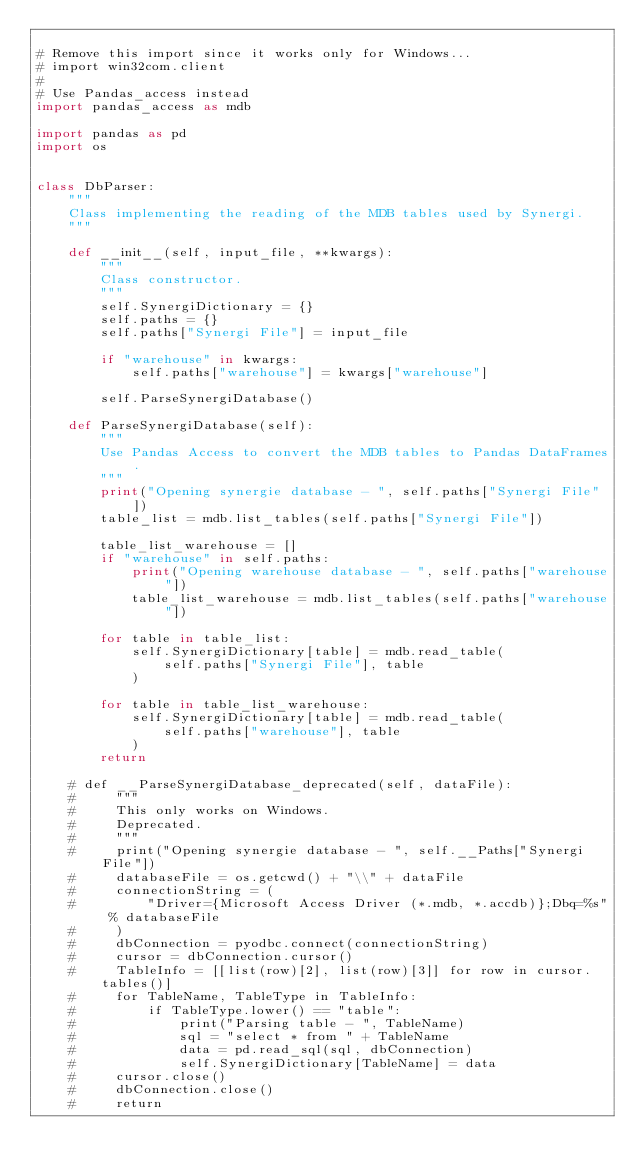<code> <loc_0><loc_0><loc_500><loc_500><_Python_>
# Remove this import since it works only for Windows...
# import win32com.client
#
# Use Pandas_access instead
import pandas_access as mdb

import pandas as pd
import os


class DbParser:
    """
    Class implementing the reading of the MDB tables used by Synergi.
    """

    def __init__(self, input_file, **kwargs):
        """
        Class constructor.
        """
        self.SynergiDictionary = {}
        self.paths = {}
        self.paths["Synergi File"] = input_file

        if "warehouse" in kwargs:
            self.paths["warehouse"] = kwargs["warehouse"]

        self.ParseSynergiDatabase()

    def ParseSynergiDatabase(self):
        """
        Use Pandas Access to convert the MDB tables to Pandas DataFrames.
        """
        print("Opening synergie database - ", self.paths["Synergi File"])
        table_list = mdb.list_tables(self.paths["Synergi File"])

        table_list_warehouse = []
        if "warehouse" in self.paths:
            print("Opening warehouse database - ", self.paths["warehouse"])
            table_list_warehouse = mdb.list_tables(self.paths["warehouse"])

        for table in table_list:
            self.SynergiDictionary[table] = mdb.read_table(
                self.paths["Synergi File"], table
            )

        for table in table_list_warehouse:
            self.SynergiDictionary[table] = mdb.read_table(
                self.paths["warehouse"], table
            )
        return

    # def __ParseSynergiDatabase_deprecated(self, dataFile):
    #     """
    #     This only works on Windows.
    #     Deprecated.
    #     """
    #     print("Opening synergie database - ", self.__Paths["Synergi File"])
    #     databaseFile = os.getcwd() + "\\" + dataFile
    #     connectionString = (
    #         "Driver={Microsoft Access Driver (*.mdb, *.accdb)};Dbq=%s" % databaseFile
    #     )
    #     dbConnection = pyodbc.connect(connectionString)
    #     cursor = dbConnection.cursor()
    #     TableInfo = [[list(row)[2], list(row)[3]] for row in cursor.tables()]
    #     for TableName, TableType in TableInfo:
    #         if TableType.lower() == "table":
    #             print("Parsing table - ", TableName)
    #             sql = "select * from " + TableName
    #             data = pd.read_sql(sql, dbConnection)
    #             self.SynergiDictionary[TableName] = data
    #     cursor.close()
    #     dbConnection.close()
    #     return
</code> 